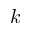Convert formula to latex. <formula><loc_0><loc_0><loc_500><loc_500>k</formula> 